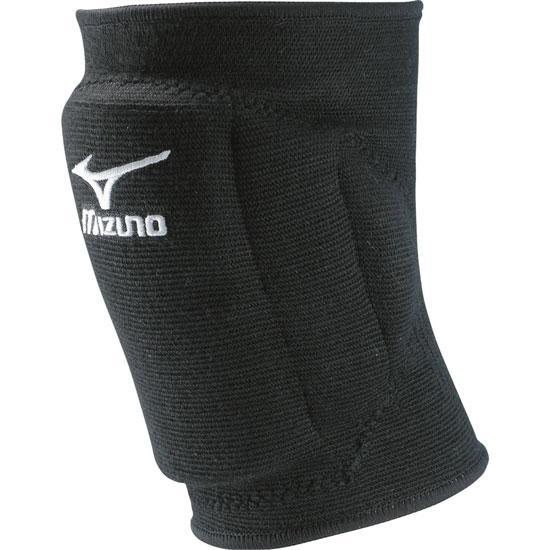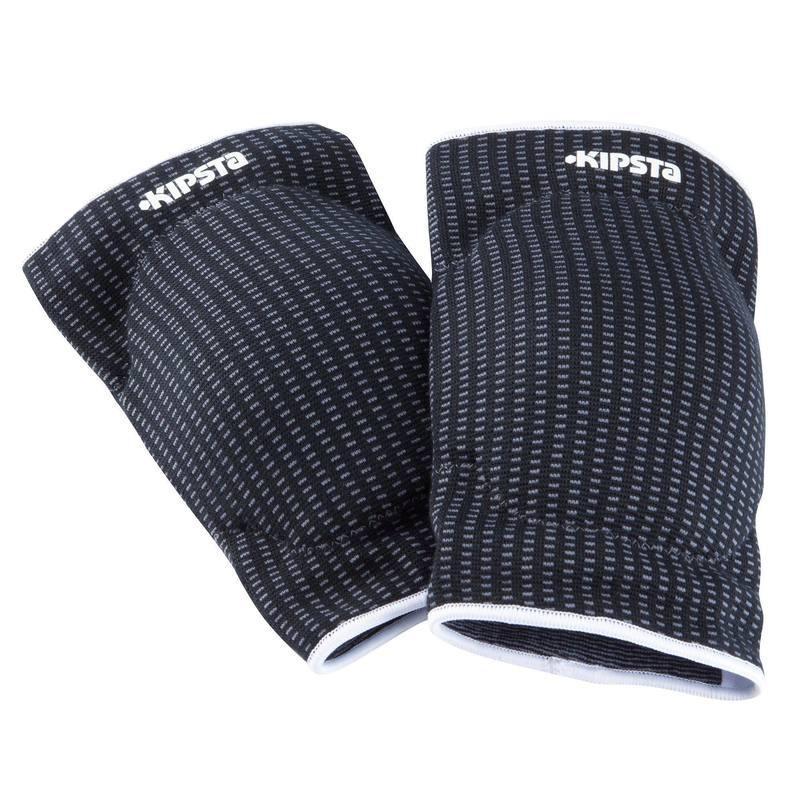The first image is the image on the left, the second image is the image on the right. Examine the images to the left and right. Is the description "At least one white knee brace with black logo is shown in one image." accurate? Answer yes or no. No. 